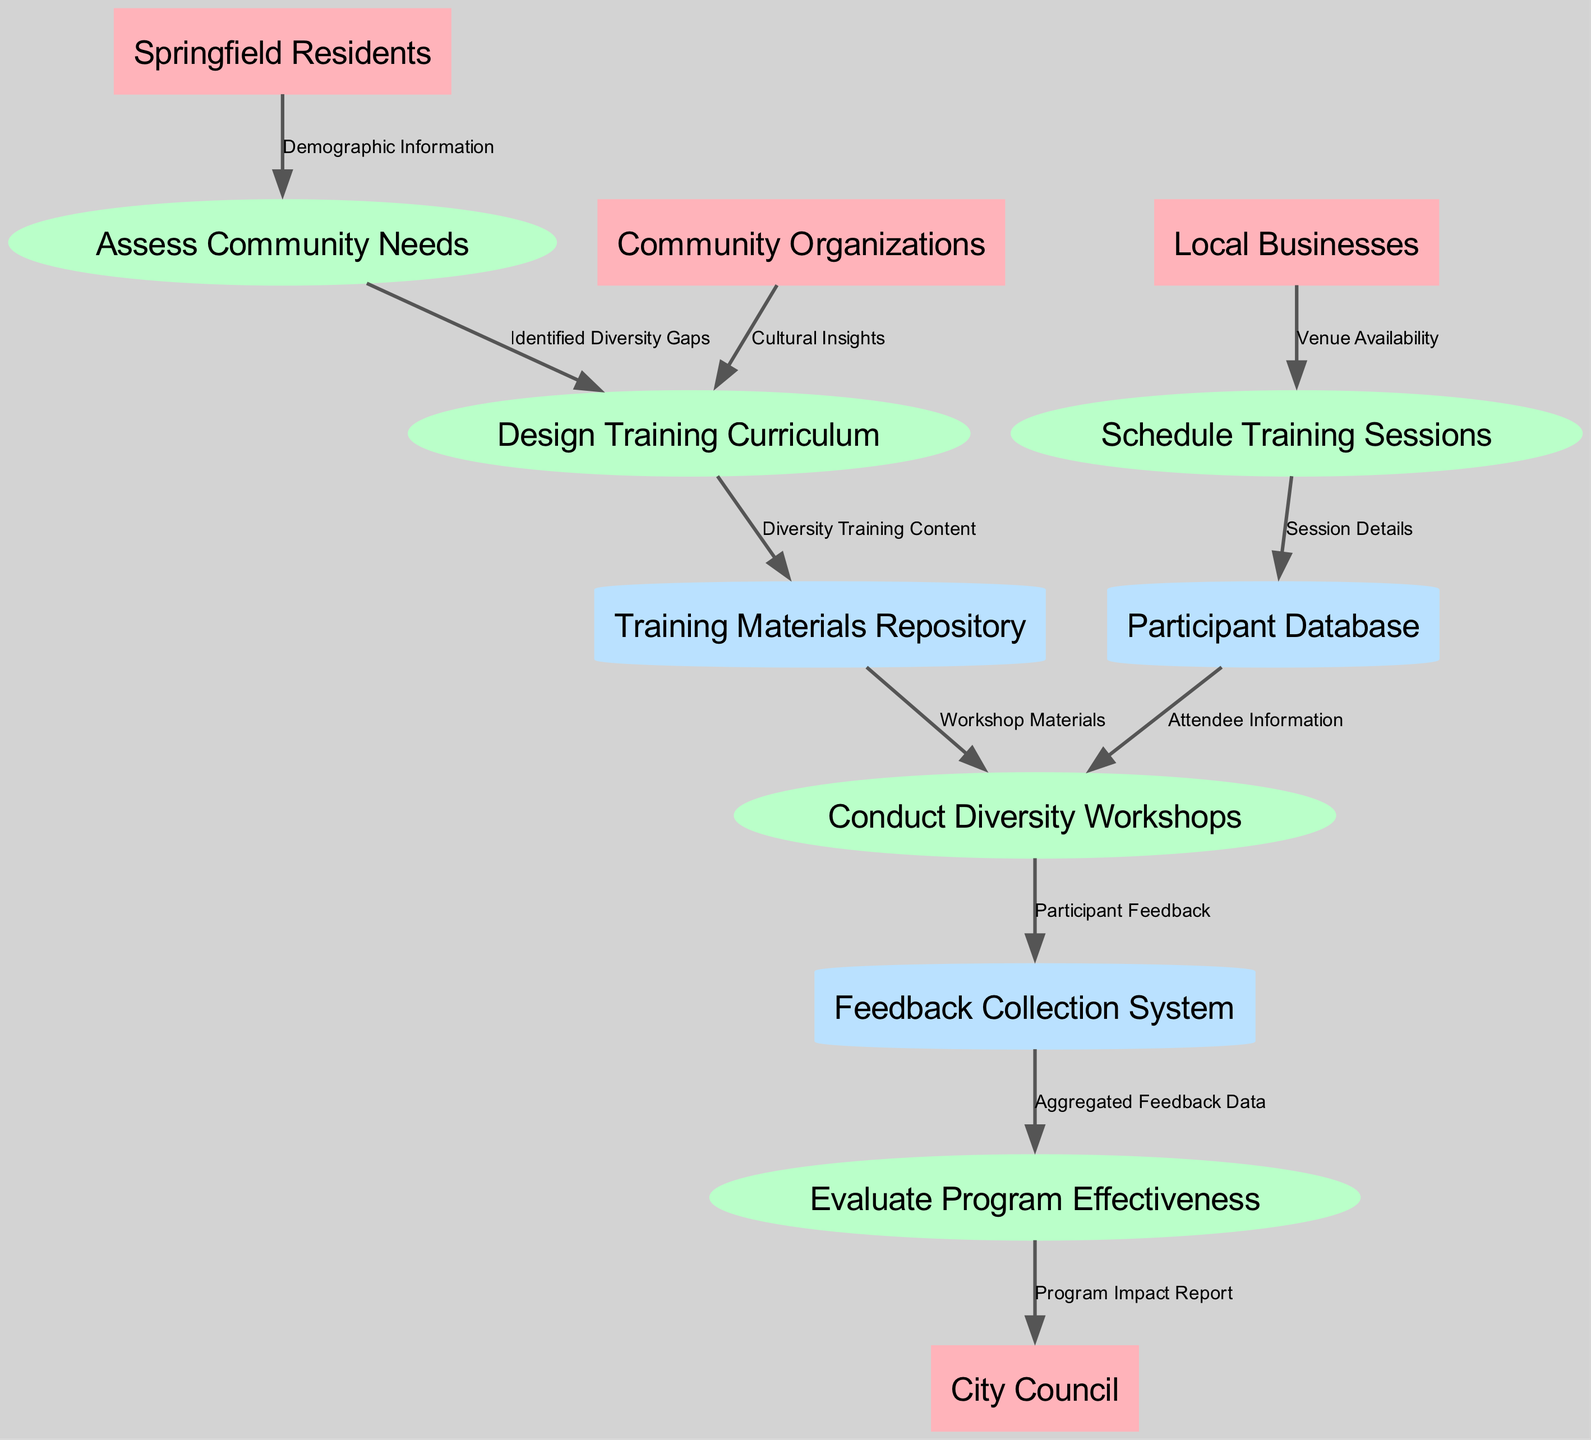What are the external entities involved in the diagram? The external entities listed in the diagram are Springfield Residents, Local Businesses, Community Organizations, and City Council. These represent groups that interact with the training program.
Answer: Springfield Residents, Local Businesses, Community Organizations, City Council How many processes are shown in the diagram? There are five processes detailed in the diagram: Assess Community Needs, Design Training Curriculum, Schedule Training Sessions, Conduct Diversity Workshops, and Evaluate Program Effectiveness. Counting them provides the total number of processes.
Answer: Five Which process receives "Demographic Information" as input? "Demographic Information" flows from Springfield Residents to the process Assess Community Needs, indicating this is the process that is informed by the demographic data.
Answer: Assess Community Needs What data store is used to hold workshop materials? The data store labeled as "Training Materials Repository" serves to hold workshop materials needed for the diversity workshops, as indicated by the flow of data to Conduct Diversity Workshops.
Answer: Training Materials Repository Which process outputs the "Program Impact Report"? The process Evaluate Program Effectiveness outputs the "Program Impact Report" to the City Council, showing the conclusion of the program's evaluation phase.
Answer: Evaluate Program Effectiveness What input does the "Design Training Curriculum" process receive from Community Organizations? The input received by the "Design Training Curriculum" process from Community Organizations is "Cultural Insights," which helps in shaping the curriculum to be more inclusive.
Answer: Cultural Insights Which two processes are directly connected by the flow “Identified Diversity Gaps”? The flow "Identified Diversity Gaps" connects the processes Assess Community Needs and Design Training Curriculum, illustrating that the identified needs inform the curriculum design.
Answer: Assess Community Needs, Design Training Curriculum How many distinct data stores are in the diagram? There are three distinct data stores in the diagram: Participant Database, Training Materials Repository, and Feedback Collection System, as identified in the data flows.
Answer: Three Which entity provides "Venue Availability" to the "Schedule Training Sessions" process? "Venue Availability" is provided by Local Businesses to the "Schedule Training Sessions" process, indicating collaboration with local businesses for training logistics.
Answer: Local Businesses 